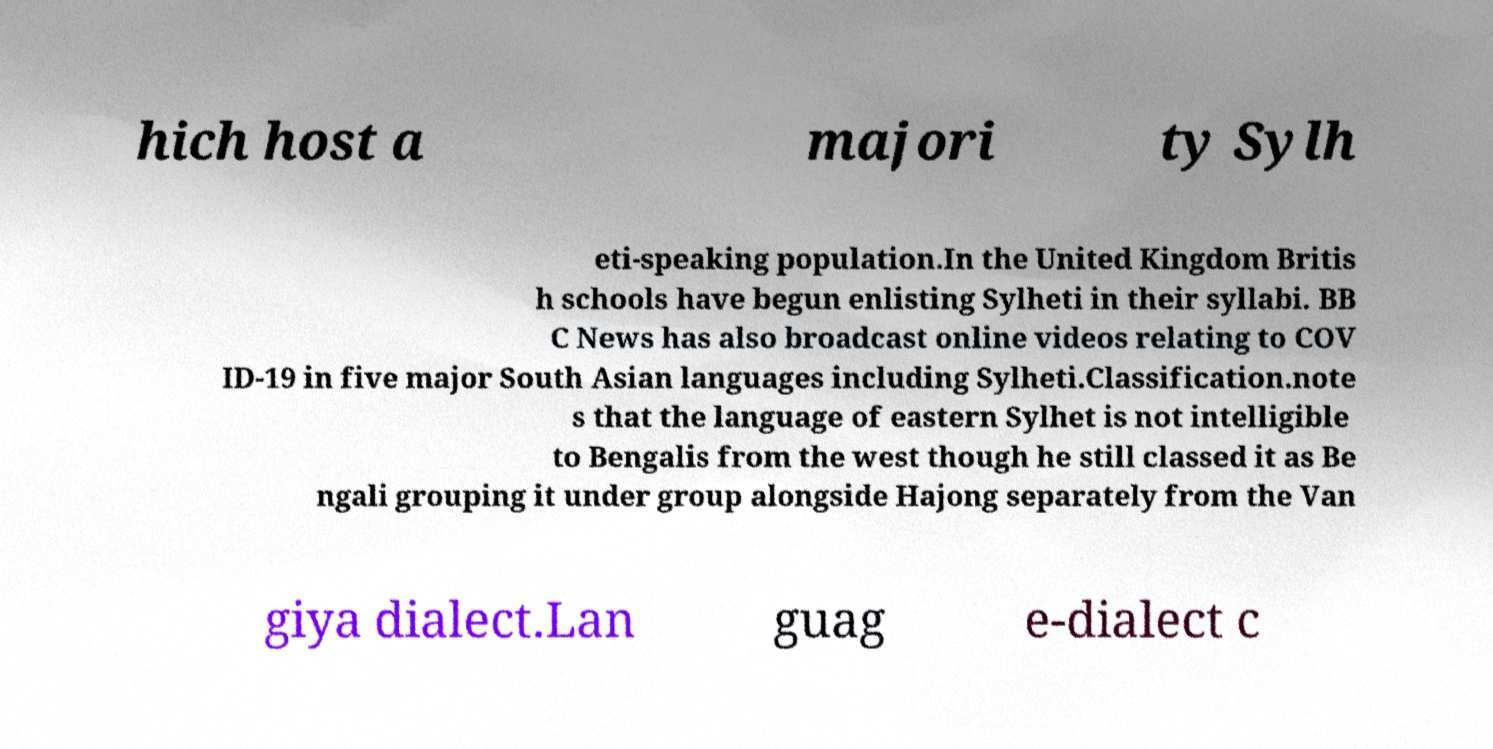What messages or text are displayed in this image? I need them in a readable, typed format. hich host a majori ty Sylh eti-speaking population.In the United Kingdom Britis h schools have begun enlisting Sylheti in their syllabi. BB C News has also broadcast online videos relating to COV ID-19 in five major South Asian languages including Sylheti.Classification.note s that the language of eastern Sylhet is not intelligible to Bengalis from the west though he still classed it as Be ngali grouping it under group alongside Hajong separately from the Van giya dialect.Lan guag e-dialect c 